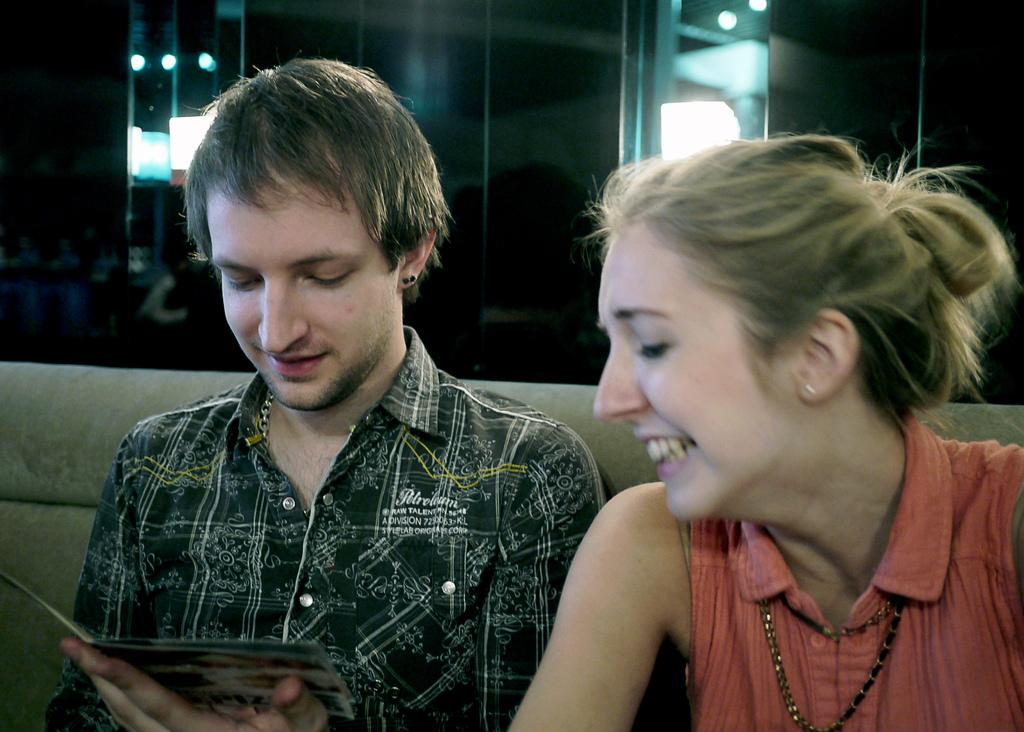How many people are in the image? There are two people in the image, a man and a woman. What are the man and woman doing in the image? Both the man and woman are sitting on a couch. What is the man holding in his hands? The man is holding a paper in his hands. What type of wood can be seen on the dock in the image? There is no dock or wood present in the image; it features a man and a woman sitting on a couch. 